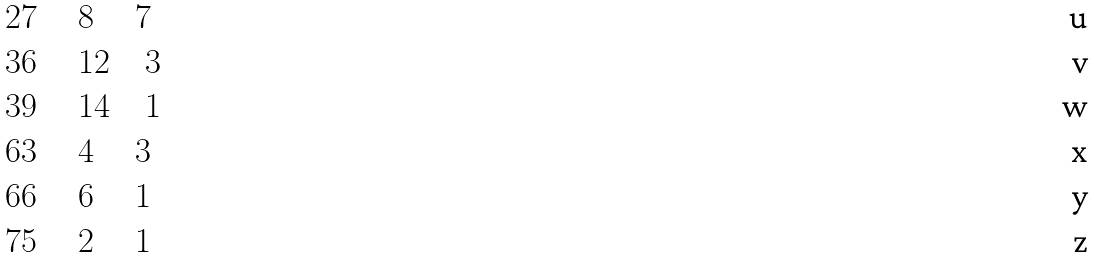Convert formula to latex. <formula><loc_0><loc_0><loc_500><loc_500>& 2 7 \quad \ 8 \quad \ 7 \\ & 3 6 \quad \ 1 2 \quad 3 \\ & 3 9 \quad \ 1 4 \quad 1 \\ & 6 3 \quad \ 4 \quad \ 3 \\ & 6 6 \quad \ 6 \quad \ 1 \\ & 7 5 \quad \ 2 \quad \ 1</formula> 